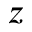<formula> <loc_0><loc_0><loc_500><loc_500>z</formula> 